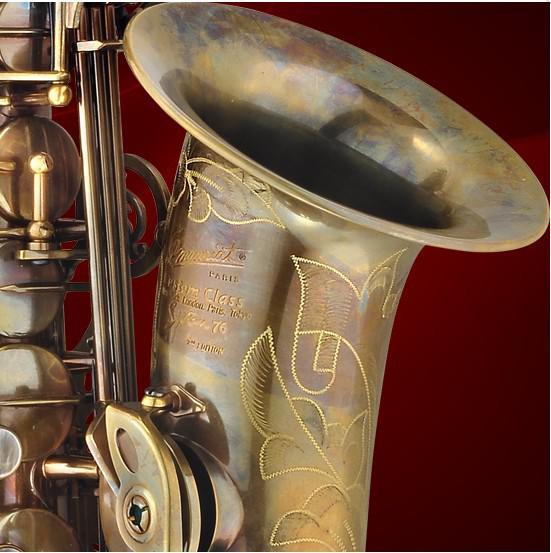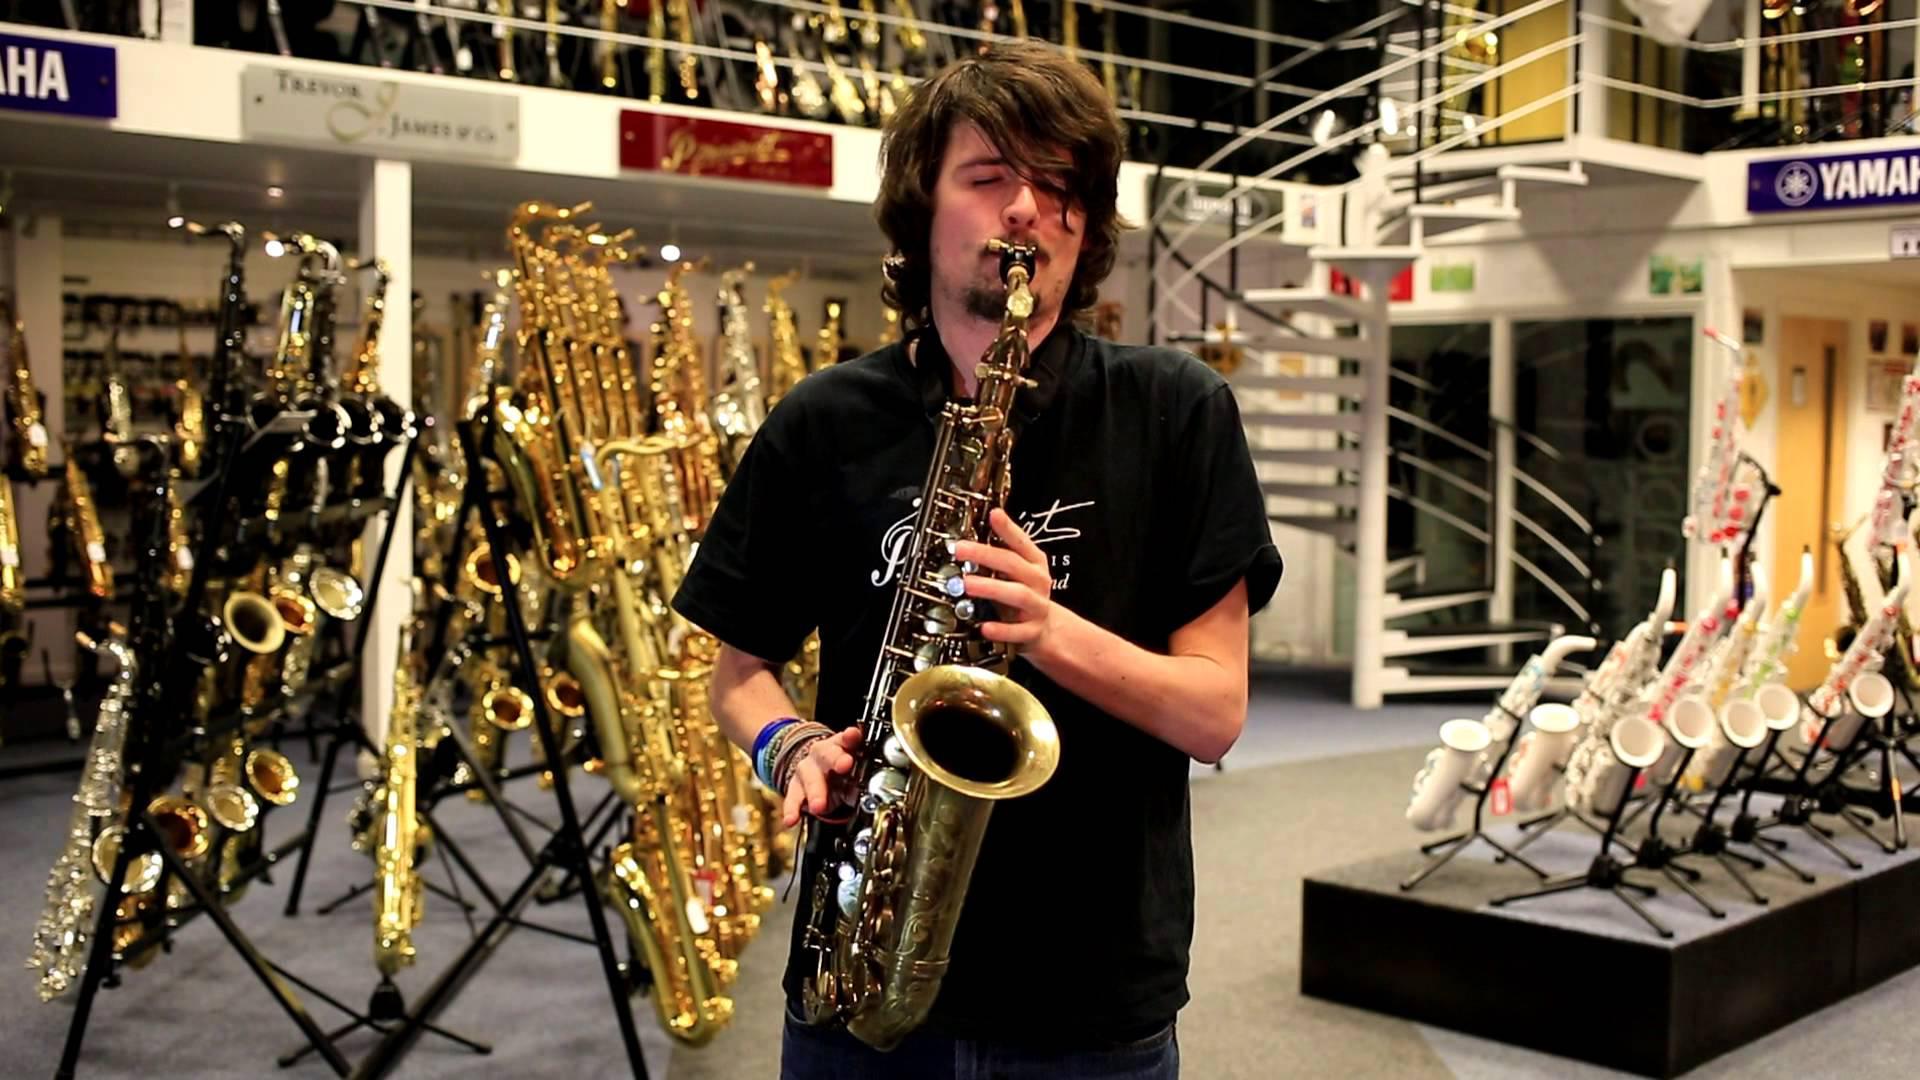The first image is the image on the left, the second image is the image on the right. For the images displayed, is the sentence "There are at most four and at least three saxophones in the right image." factually correct? Answer yes or no. No. The first image is the image on the left, the second image is the image on the right. Analyze the images presented: Is the assertion "In the left image, there is only one saxophone, of which you can see the entire instrument." valid? Answer yes or no. No. 